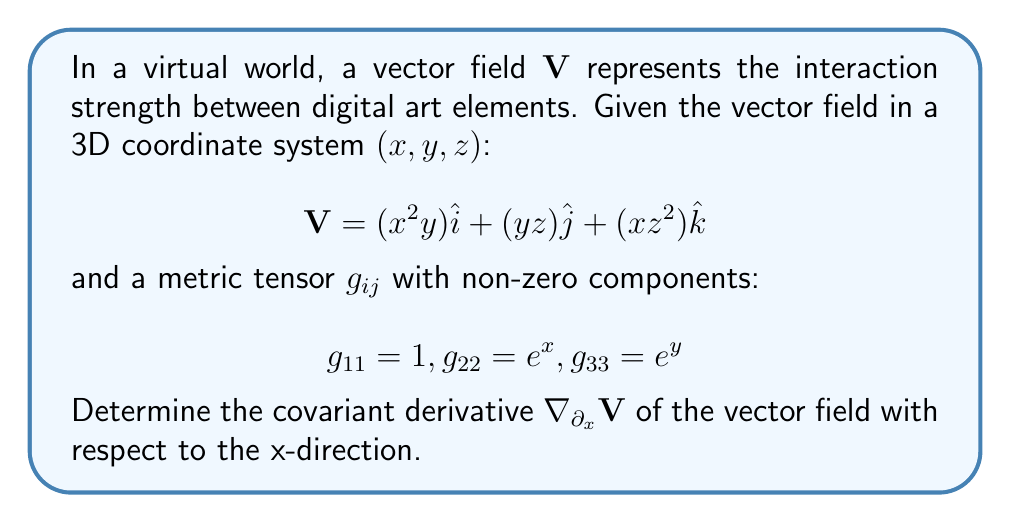Could you help me with this problem? To find the covariant derivative $\nabla_{\partial_x}\mathbf{V}$, we need to follow these steps:

1) The general formula for the covariant derivative is:

   $$(\nabla_{\partial_x}\mathbf{V})^i = \partial_x V^i + \Gamma^i_{jx}V^j$$

   where $\Gamma^i_{jx}$ are the Christoffel symbols.

2) First, let's calculate $\partial_x V^i$:
   
   $$\partial_x V^1 = 2xy$$
   $$\partial_x V^2 = 0$$
   $$\partial_x V^3 = z^2$$

3) Next, we need to calculate the relevant Christoffel symbols. The formula is:

   $$\Gamma^i_{jk} = \frac{1}{2}g^{im}(\partial_j g_{km} + \partial_k g_{jm} - \partial_m g_{jk})$$

   We only need $\Gamma^i_{jx}$ for this problem.

4) Calculate $g^{ij}$ (inverse of $g_{ij}$):

   $$g^{11} = 1, g^{22} = e^{-x}, g^{33} = e^{-y}$$

5) The non-zero Christoffel symbols we need are:

   $$\Gamma^2_{2x} = \frac{1}{2}g^{22}\partial_x g_{22} = \frac{1}{2}e^{-x} \cdot e^x = \frac{1}{2}$$

   All other $\Gamma^i_{jx} = 0$

6) Now we can calculate each component of $\nabla_{\partial_x}\mathbf{V}$:

   $$(\nabla_{\partial_x}\mathbf{V})^1 = \partial_x V^1 + \Gamma^1_{jx}V^j = 2xy + 0 = 2xy$$
   
   $$(\nabla_{\partial_x}\mathbf{V})^2 = \partial_x V^2 + \Gamma^2_{jx}V^j = 0 + \Gamma^2_{2x}V^2 = \frac{1}{2} \cdot yz = \frac{1}{2}yz$$
   
   $$(\nabla_{\partial_x}\mathbf{V})^3 = \partial_x V^3 + \Gamma^3_{jx}V^j = z^2 + 0 = z^2$$

7) Therefore, the covariant derivative is:

   $$\nabla_{\partial_x}\mathbf{V} = (2xy)\hat{i} + (\frac{1}{2}yz)\hat{j} + (z^2)\hat{k}$$
Answer: $$(2xy)\hat{i} + (\frac{1}{2}yz)\hat{j} + (z^2)\hat{k}$$ 